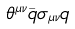<formula> <loc_0><loc_0><loc_500><loc_500>\theta ^ { \mu \nu } \bar { q } \sigma _ { \mu \nu } q</formula> 